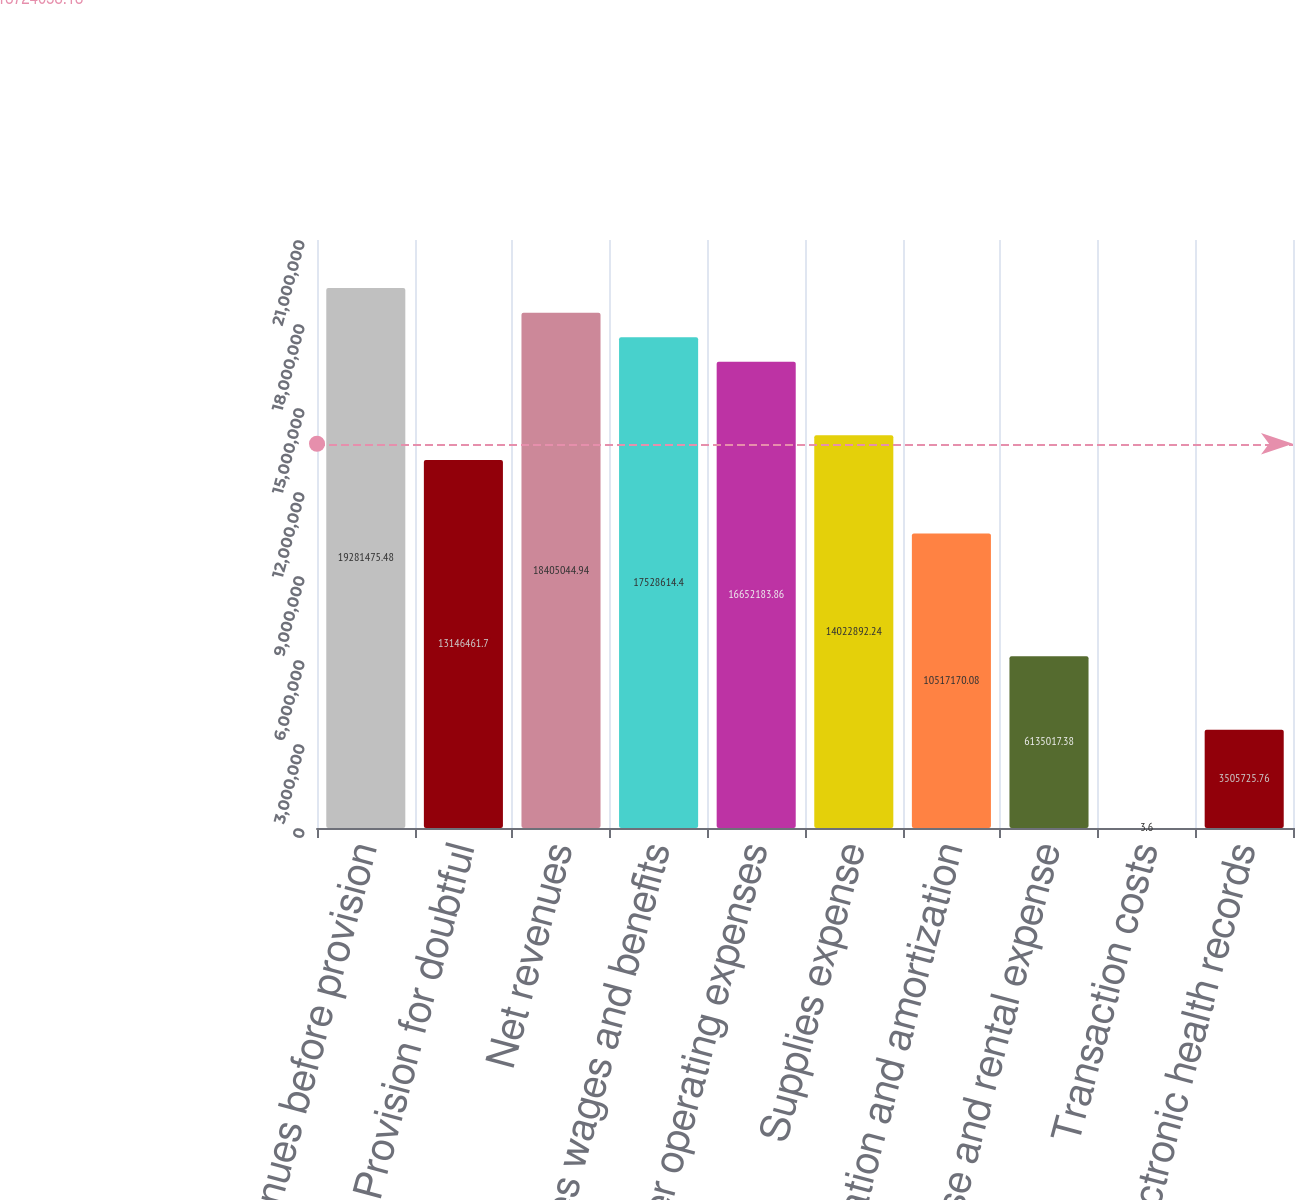Convert chart. <chart><loc_0><loc_0><loc_500><loc_500><bar_chart><fcel>Net revenues before provision<fcel>Less Provision for doubtful<fcel>Net revenues<fcel>Salaries wages and benefits<fcel>Other operating expenses<fcel>Supplies expense<fcel>Depreciation and amortization<fcel>Lease and rental expense<fcel>Transaction costs<fcel>Electronic health records<nl><fcel>1.92815e+07<fcel>1.31465e+07<fcel>1.8405e+07<fcel>1.75286e+07<fcel>1.66522e+07<fcel>1.40229e+07<fcel>1.05172e+07<fcel>6.13502e+06<fcel>3.6<fcel>3.50573e+06<nl></chart> 